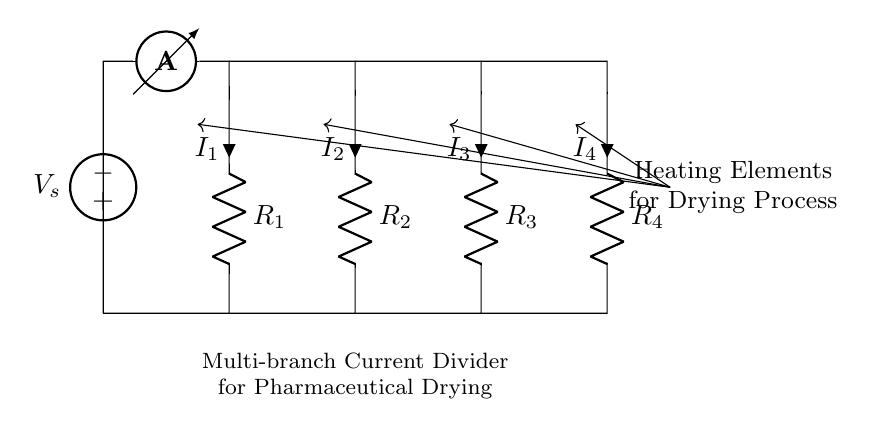What is the total number of resistors in the circuit? The circuit diagram shows four resistors labeled R1, R2, R3, and R4 connected in parallel, indicating a total count of four resistors.
Answer: 4 What is the type of voltage source used in the circuit? The circuit includes an "american voltage source" labeled as V_s, which is a direct current (DC) voltage source depicted in the diagram.
Answer: american voltage source What is the current flowing through resistor R2? The current through each resistor in a current divider can vary depending on their resistance values, but in this context, it is labeled as I2, representing the current flowing through R2.
Answer: I2 How many branches are present in the circuit? Each resistor represents a branch receiving a portion of the total current from the voltage source, therefore, with R1, R2, R3, and R4, there are four distinct branches in the circuit.
Answer: 4 Which component is responsible for supplying power in the circuit? The "american voltage source" labeled as V_s provides the necessary electrical energy to the circuit in order to power the heating elements represented by the resistors.
Answer: american voltage source What is the primary function of this multi-branch current divider? The primary function of this current divider is to distribute the total input current among the multiple branches (or resistors) to control the power delivered to each heating element uniformly during the drying process in pharmaceuticals.
Answer: distribute current How does the configuration of resistors affect the individual current values? In a parallel configuration like this, the total current from the source is divided inversely proportional to the resistance values of each branch, meaning lower resistance leads to higher current, affecting how much heating occurs in each element.
Answer: inversely proportional 